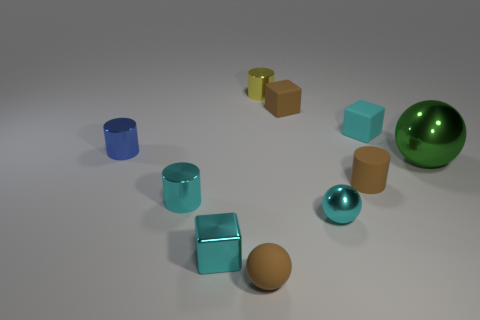Is there anything else that is the same size as the green metal object?
Offer a terse response. No. Is there a metallic sphere of the same color as the big metallic object?
Your answer should be very brief. No. How many large things are green metal spheres or purple rubber cylinders?
Provide a succinct answer. 1. There is a tiny thing that is to the right of the small brown rubber ball and in front of the small brown matte cylinder; what is its shape?
Keep it short and to the point. Sphere. Is the material of the yellow object the same as the brown cube?
Your answer should be compact. No. The rubber sphere that is the same size as the cyan shiny cylinder is what color?
Offer a terse response. Brown. There is a tiny cylinder that is both right of the small brown matte sphere and in front of the tiny yellow metal thing; what is its color?
Make the answer very short. Brown. The cylinder that is the same color as the matte ball is what size?
Ensure brevity in your answer.  Small. There is a tiny rubber object that is the same color as the small metallic sphere; what is its shape?
Your answer should be compact. Cube. There is a cube that is on the left side of the brown matte object in front of the tiny matte cylinder that is to the right of the small metallic sphere; how big is it?
Your response must be concise. Small. 